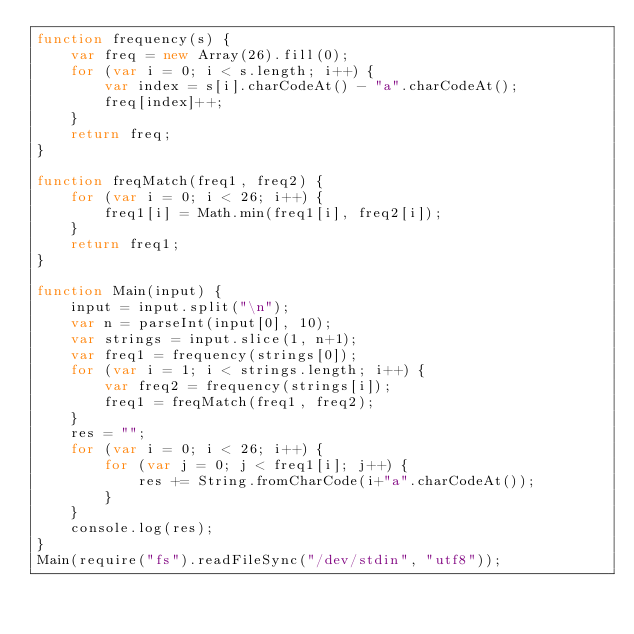<code> <loc_0><loc_0><loc_500><loc_500><_JavaScript_>function frequency(s) {
    var freq = new Array(26).fill(0);
    for (var i = 0; i < s.length; i++) {
        var index = s[i].charCodeAt() - "a".charCodeAt();
        freq[index]++;
    }
    return freq;
}

function freqMatch(freq1, freq2) {
    for (var i = 0; i < 26; i++) {
        freq1[i] = Math.min(freq1[i], freq2[i]);
    }
    return freq1;
}

function Main(input) {
    input = input.split("\n");
    var n = parseInt(input[0], 10);
    var strings = input.slice(1, n+1);
    var freq1 = frequency(strings[0]);
    for (var i = 1; i < strings.length; i++) {
        var freq2 = frequency(strings[i]);
        freq1 = freqMatch(freq1, freq2);
    }
    res = "";
    for (var i = 0; i < 26; i++) {
        for (var j = 0; j < freq1[i]; j++) {
            res += String.fromCharCode(i+"a".charCodeAt());
        }
    }
    console.log(res);
}
Main(require("fs").readFileSync("/dev/stdin", "utf8"));</code> 